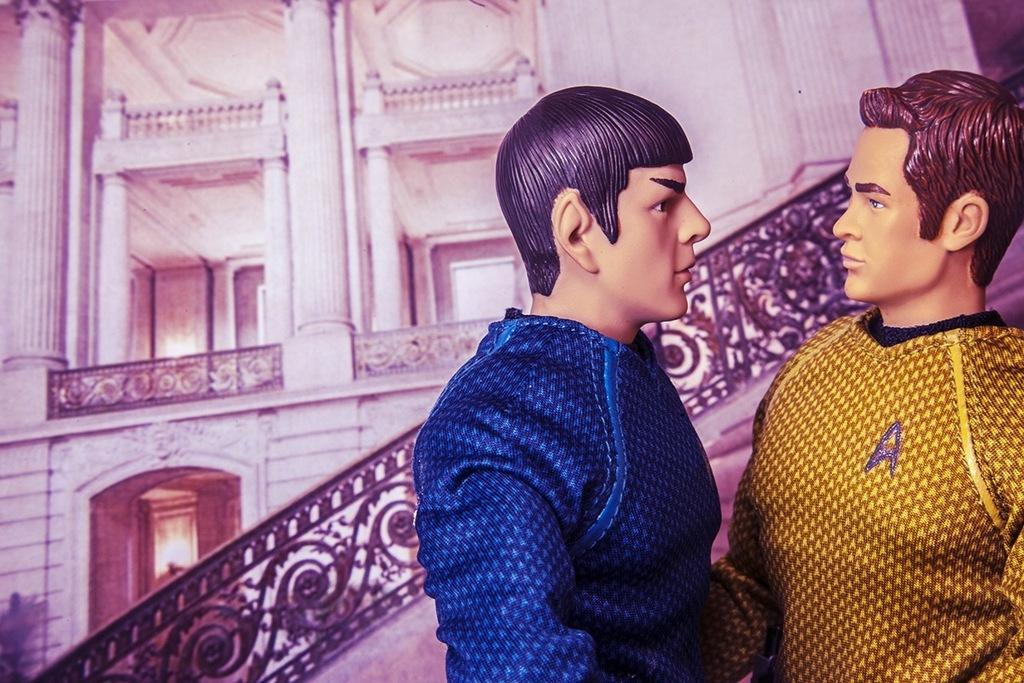How would you summarize this image in a sentence or two? In the background we can see a building. This is a black railing. We can see two men and it seems like they are toys. 